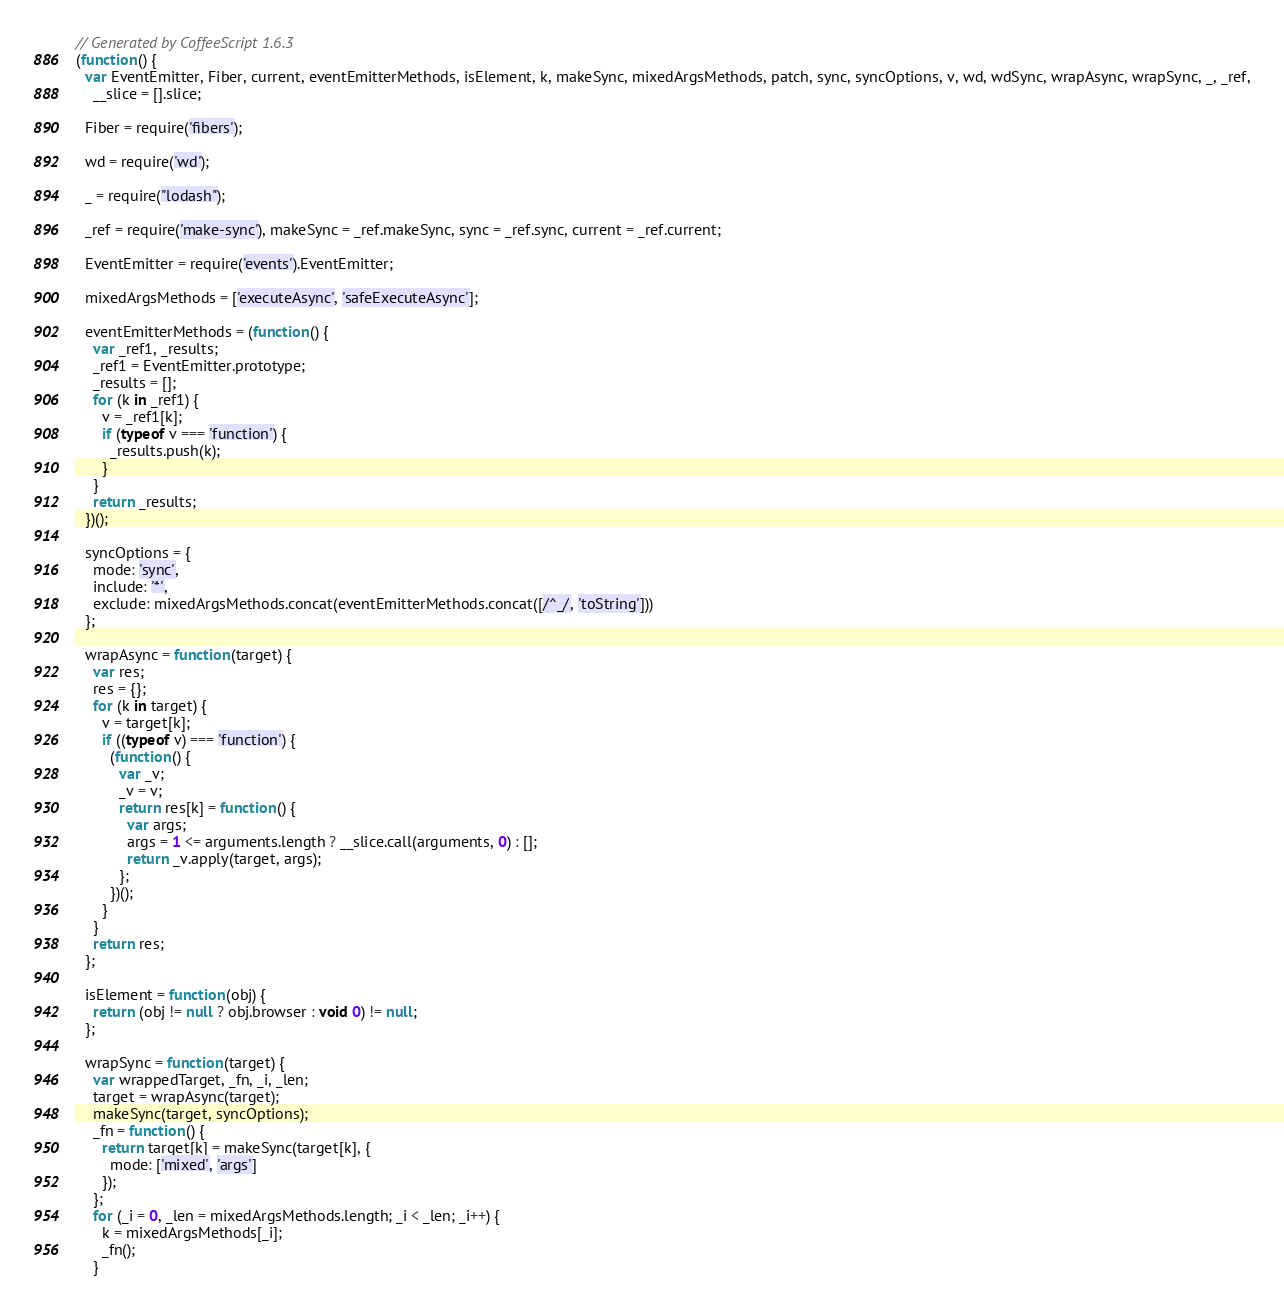<code> <loc_0><loc_0><loc_500><loc_500><_JavaScript_>// Generated by CoffeeScript 1.6.3
(function() {
  var EventEmitter, Fiber, current, eventEmitterMethods, isElement, k, makeSync, mixedArgsMethods, patch, sync, syncOptions, v, wd, wdSync, wrapAsync, wrapSync, _, _ref,
    __slice = [].slice;

  Fiber = require('fibers');

  wd = require('wd');

  _ = require("lodash");

  _ref = require('make-sync'), makeSync = _ref.makeSync, sync = _ref.sync, current = _ref.current;

  EventEmitter = require('events').EventEmitter;

  mixedArgsMethods = ['executeAsync', 'safeExecuteAsync'];

  eventEmitterMethods = (function() {
    var _ref1, _results;
    _ref1 = EventEmitter.prototype;
    _results = [];
    for (k in _ref1) {
      v = _ref1[k];
      if (typeof v === 'function') {
        _results.push(k);
      }
    }
    return _results;
  })();

  syncOptions = {
    mode: 'sync',
    include: '*',
    exclude: mixedArgsMethods.concat(eventEmitterMethods.concat([/^_/, 'toString']))
  };

  wrapAsync = function(target) {
    var res;
    res = {};
    for (k in target) {
      v = target[k];
      if ((typeof v) === 'function') {
        (function() {
          var _v;
          _v = v;
          return res[k] = function() {
            var args;
            args = 1 <= arguments.length ? __slice.call(arguments, 0) : [];
            return _v.apply(target, args);
          };
        })();
      }
    }
    return res;
  };

  isElement = function(obj) {
    return (obj != null ? obj.browser : void 0) != null;
  };

  wrapSync = function(target) {
    var wrappedTarget, _fn, _i, _len;
    target = wrapAsync(target);
    makeSync(target, syncOptions);
    _fn = function() {
      return target[k] = makeSync(target[k], {
        mode: ['mixed', 'args']
      });
    };
    for (_i = 0, _len = mixedArgsMethods.length; _i < _len; _i++) {
      k = mixedArgsMethods[_i];
      _fn();
    }</code> 